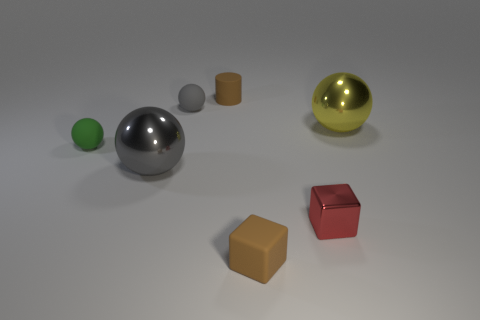Subtract all brown blocks. How many gray spheres are left? 2 Subtract all tiny gray rubber balls. How many balls are left? 3 Add 1 small brown rubber objects. How many objects exist? 8 Subtract all yellow spheres. How many spheres are left? 3 Subtract all blocks. How many objects are left? 5 Subtract all green cubes. Subtract all green spheres. How many cubes are left? 2 Add 6 shiny spheres. How many shiny spheres are left? 8 Add 7 big gray balls. How many big gray balls exist? 8 Subtract 1 yellow balls. How many objects are left? 6 Subtract all gray metallic spheres. Subtract all tiny purple cylinders. How many objects are left? 6 